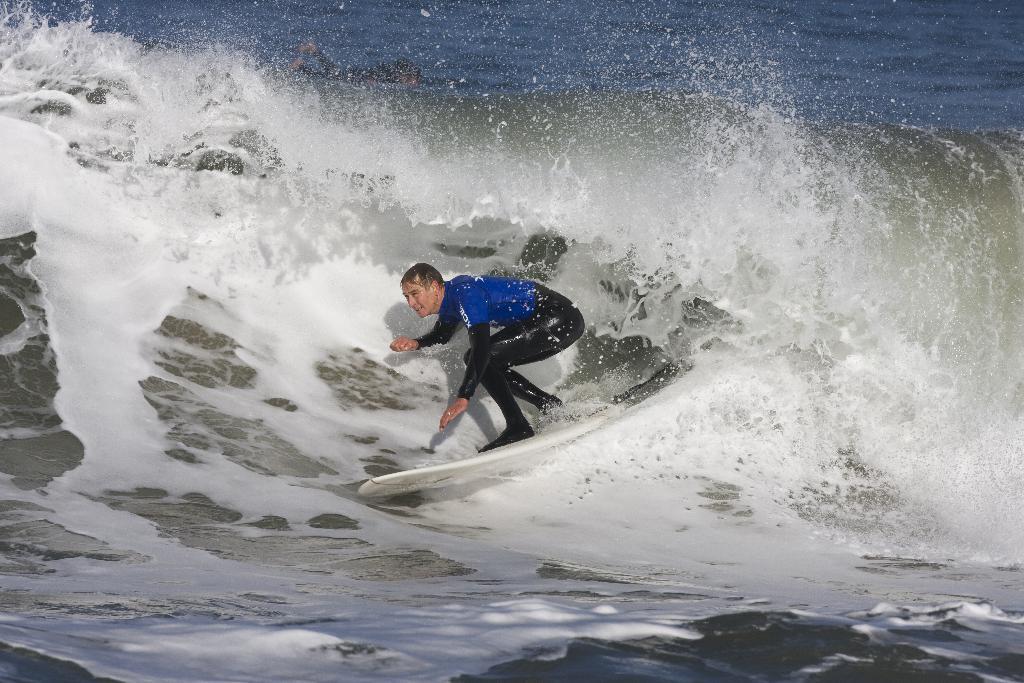Please provide a concise description of this image. In this image we can see a person surfing on the sea. 